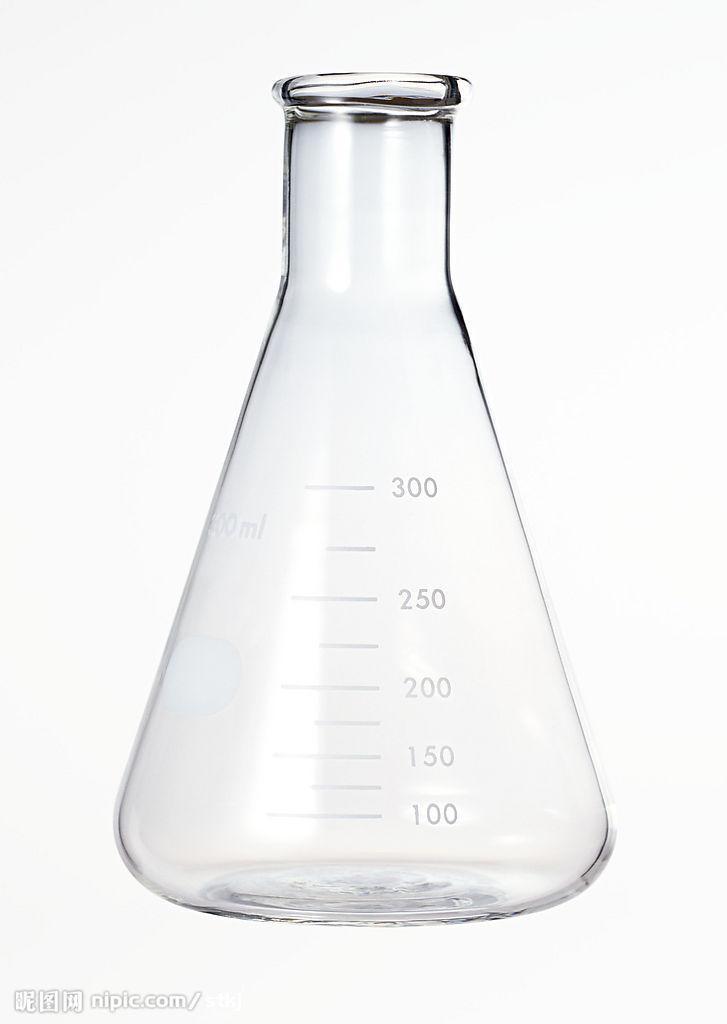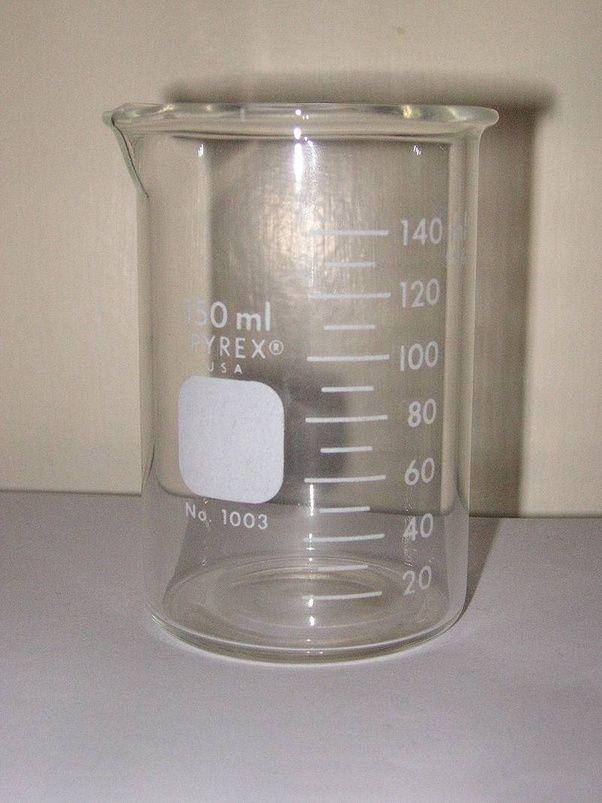The first image is the image on the left, the second image is the image on the right. For the images shown, is this caption "There are two science beakers." true? Answer yes or no. Yes. The first image is the image on the left, the second image is the image on the right. Considering the images on both sides, is "There is one empty container in the left image." valid? Answer yes or no. Yes. 